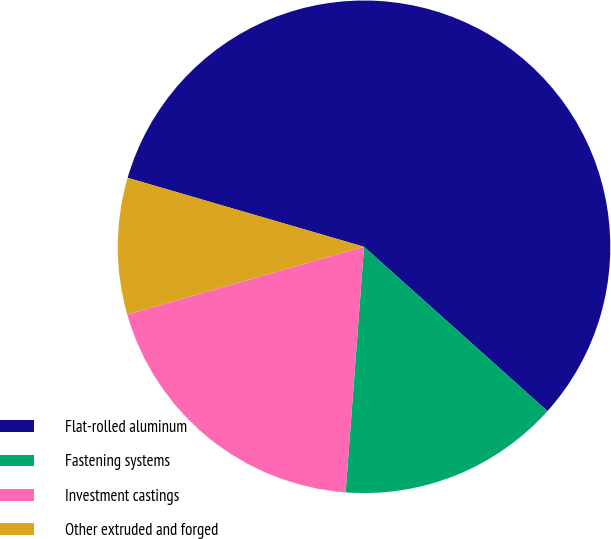Convert chart to OTSL. <chart><loc_0><loc_0><loc_500><loc_500><pie_chart><fcel>Flat-rolled aluminum<fcel>Fastening systems<fcel>Investment castings<fcel>Other extruded and forged<nl><fcel>57.11%<fcel>14.56%<fcel>19.37%<fcel>8.96%<nl></chart> 